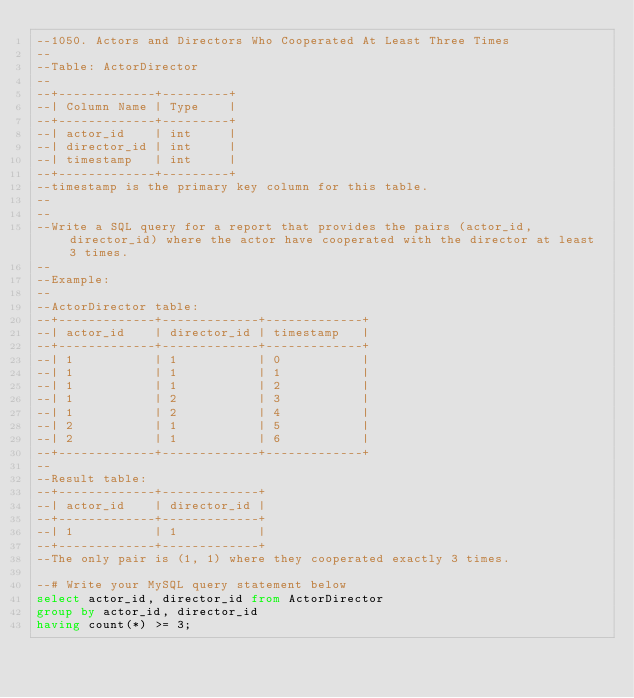<code> <loc_0><loc_0><loc_500><loc_500><_SQL_>--1050. Actors and Directors Who Cooperated At Least Three Times
--
--Table: ActorDirector
--
--+-------------+---------+
--| Column Name | Type    |
--+-------------+---------+
--| actor_id    | int     |
--| director_id | int     |
--| timestamp   | int     |
--+-------------+---------+
--timestamp is the primary key column for this table.
--
--
--Write a SQL query for a report that provides the pairs (actor_id, director_id) where the actor have cooperated with the director at least 3 times.
--
--Example:
--
--ActorDirector table:
--+-------------+-------------+-------------+
--| actor_id    | director_id | timestamp   |
--+-------------+-------------+-------------+
--| 1           | 1           | 0           |
--| 1           | 1           | 1           |
--| 1           | 1           | 2           |
--| 1           | 2           | 3           |
--| 1           | 2           | 4           |
--| 2           | 1           | 5           |
--| 2           | 1           | 6           |
--+-------------+-------------+-------------+
--
--Result table:
--+-------------+-------------+
--| actor_id    | director_id |
--+-------------+-------------+
--| 1           | 1           |
--+-------------+-------------+
--The only pair is (1, 1) where they cooperated exactly 3 times.

--# Write your MySQL query statement below
select actor_id, director_id from ActorDirector
group by actor_id, director_id
having count(*) >= 3;</code> 